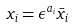Convert formula to latex. <formula><loc_0><loc_0><loc_500><loc_500>x _ { i } = \epsilon ^ { a _ { i } } \bar { x } _ { i }</formula> 